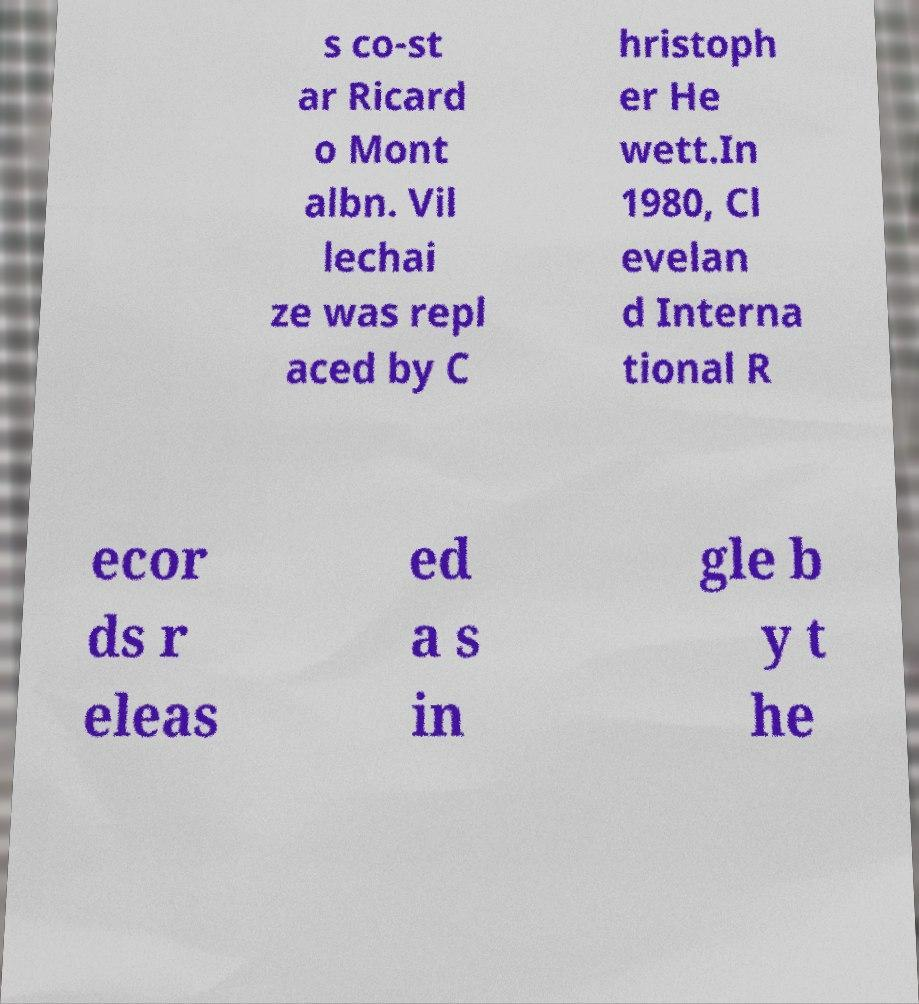Could you extract and type out the text from this image? s co-st ar Ricard o Mont albn. Vil lechai ze was repl aced by C hristoph er He wett.In 1980, Cl evelan d Interna tional R ecor ds r eleas ed a s in gle b y t he 